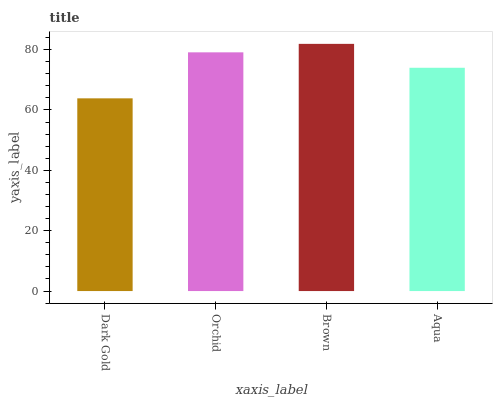Is Dark Gold the minimum?
Answer yes or no. Yes. Is Brown the maximum?
Answer yes or no. Yes. Is Orchid the minimum?
Answer yes or no. No. Is Orchid the maximum?
Answer yes or no. No. Is Orchid greater than Dark Gold?
Answer yes or no. Yes. Is Dark Gold less than Orchid?
Answer yes or no. Yes. Is Dark Gold greater than Orchid?
Answer yes or no. No. Is Orchid less than Dark Gold?
Answer yes or no. No. Is Orchid the high median?
Answer yes or no. Yes. Is Aqua the low median?
Answer yes or no. Yes. Is Aqua the high median?
Answer yes or no. No. Is Orchid the low median?
Answer yes or no. No. 